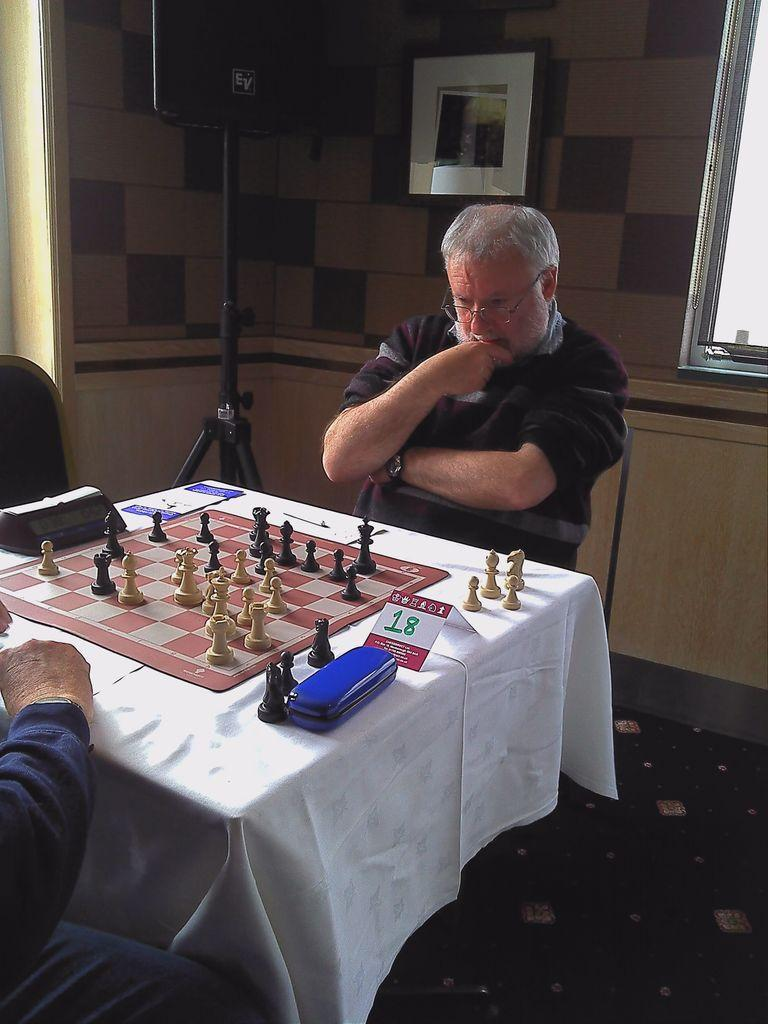How many people are in the image? There are two persons sitting in the image. What is in front of the persons? There is a table in front of the persons. What is on the table? A chess board is present on the table. What can be seen on the wall behind the persons? There is a frame attached to the wall at the back side of the image. How much money is on the chess board in the image? There is no money present on the chess board in the image; it is a game board for playing chess. 